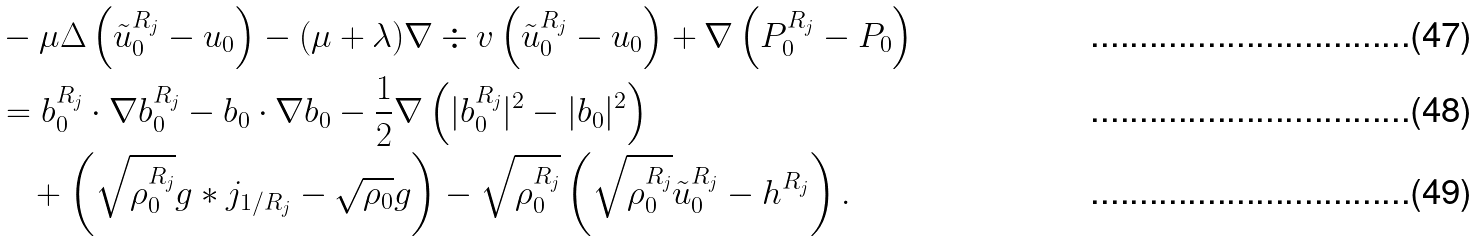<formula> <loc_0><loc_0><loc_500><loc_500>& - \mu \Delta \left ( \tilde { u } _ { 0 } ^ { R _ { j } } - u _ { 0 } \right ) - ( \mu + \lambda ) \nabla \div v \left ( \tilde { u } _ { 0 } ^ { R _ { j } } - u _ { 0 } \right ) + \nabla \left ( P ^ { R _ { j } } _ { 0 } - P _ { 0 } \right ) \\ & = b _ { 0 } ^ { R _ { j } } \cdot \nabla b _ { 0 } ^ { R _ { j } } - b _ { 0 } \cdot \nabla b _ { 0 } - \frac { 1 } { 2 } \nabla \left ( | b _ { 0 } ^ { R _ { j } } | ^ { 2 } - | b _ { 0 } | ^ { 2 } \right ) \\ & \quad + \left ( \sqrt { \rho _ { 0 } ^ { R _ { j } } } g * j _ { 1 / R _ { j } } - \sqrt { \rho _ { 0 } } g \right ) - \sqrt { \rho _ { 0 } ^ { R _ { j } } } \left ( \sqrt { \rho _ { 0 } ^ { R _ { j } } } \tilde { u } _ { 0 } ^ { R _ { j } } - h ^ { R _ { j } } \right ) .</formula> 